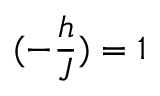<formula> <loc_0><loc_0><loc_500><loc_500>( - \frac { h } { J } ) = 1</formula> 